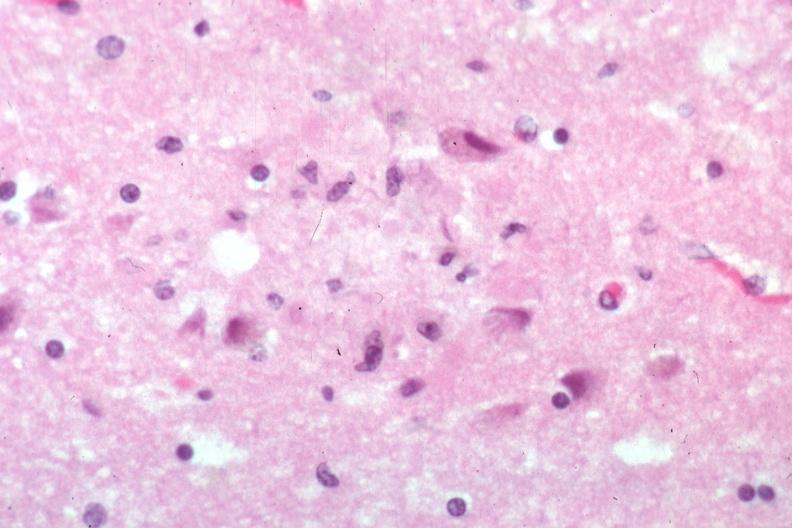what is present?
Answer the question using a single word or phrase. Brain 